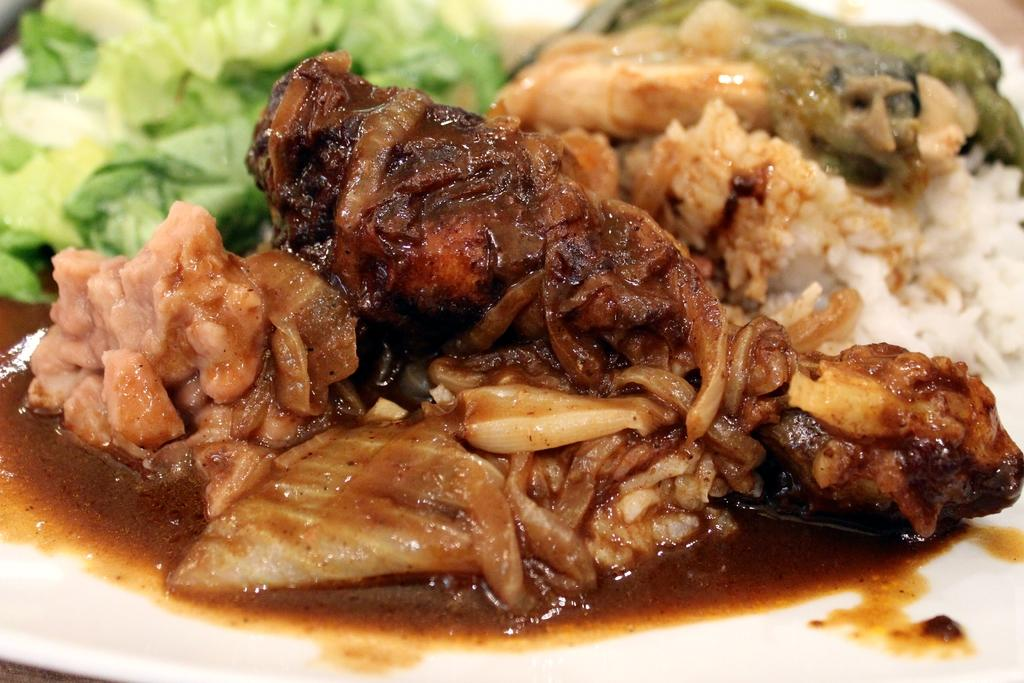What type of food item is on the plate in the image? There is a food item on a plate in the image, which includes vegetables, cooked meat, and rice. Can you describe the vegetables on the plate? The vegetables on the plate are not specified, but they are present alongside the cooked meat and rice. What other food item is on the plate? In addition to the vegetables, there is cooked meat and rice on the plate. What color is the mitten that is being used to eat the food on the plate? There is no mitten present in the image; it is a plate of food with vegetables, cooked meat, and rice. 